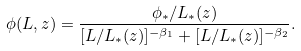<formula> <loc_0><loc_0><loc_500><loc_500>\phi ( L , z ) = \frac { \phi _ { * } / L _ { * } ( z ) } { [ L / L _ { * } ( z ) ] ^ { - \beta _ { 1 } } + [ L / L _ { * } ( z ) ] ^ { - \beta _ { 2 } } } .</formula> 